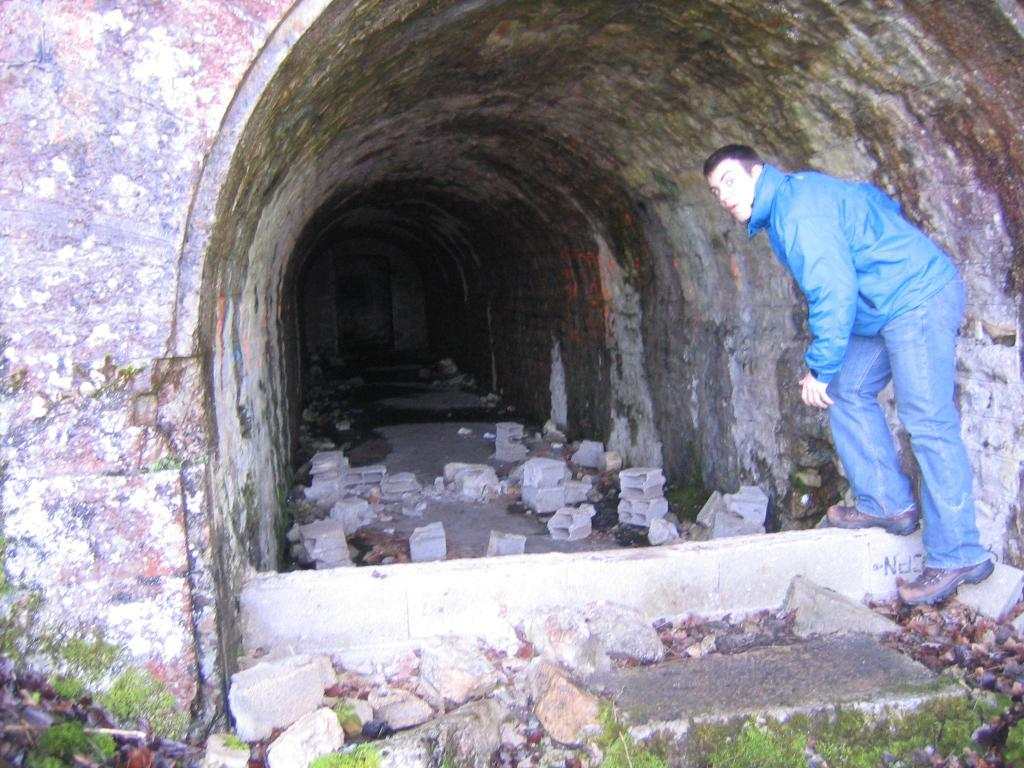What is the main feature of the image? There is a tunnel in the image. Who is present in the image? A man is present in the image. What is the man wearing? The man is wearing a jacket and shoes. What is the man's posture in the image? The man is standing. What type of ground is visible in the image? Stones and grass are visible on the ground. What does the man's aunt say to him as he leaves with his doll in the image? There is no mention of a doll or the man's aunt in the image. 